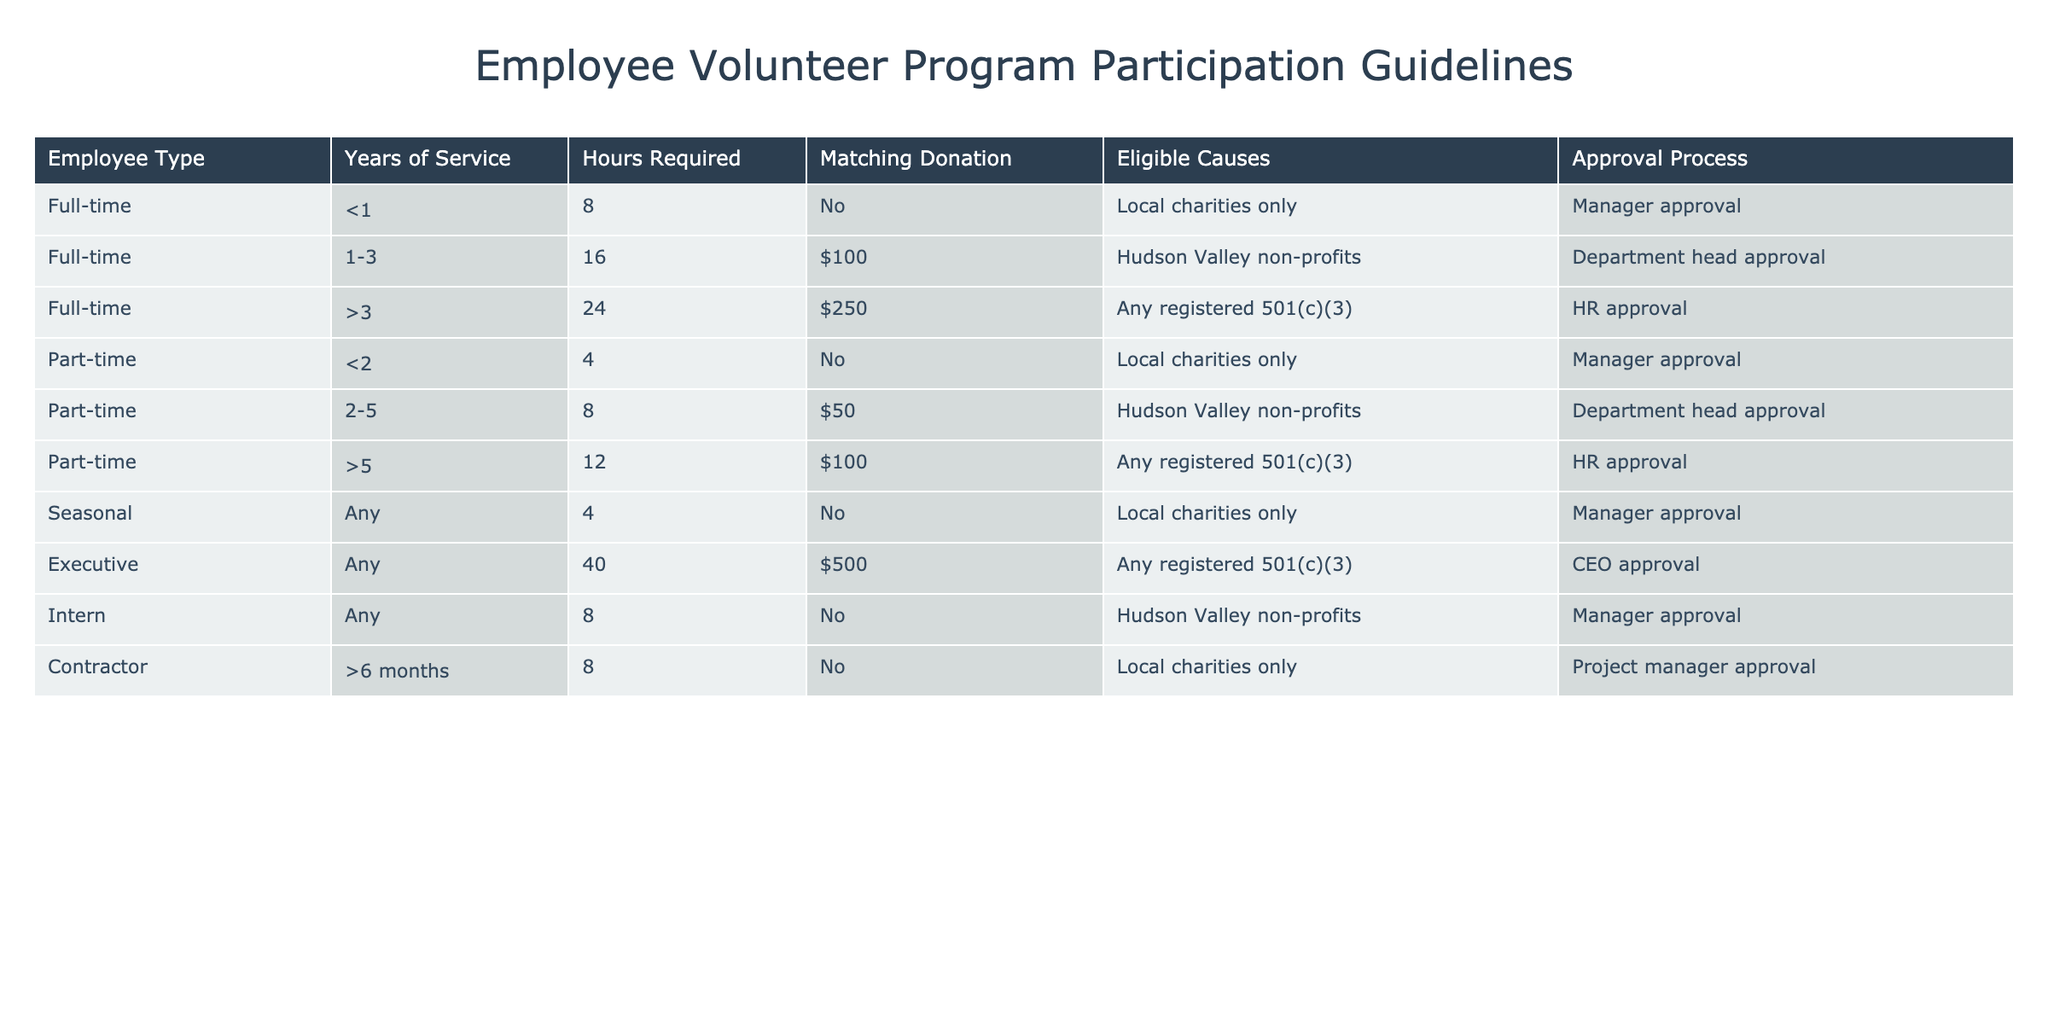What is the approval process for full-time employees with more than 3 years of service? According to the table, full-time employees with more than 3 years of service require HR approval for participation in the volunteer program.
Answer: HR approval How many hours are required for part-time employees with at least 2 years but less than 5 years of service? Part-time employees with 2 to 5 years of service are required to complete 8 hours of volunteer work.
Answer: 8 hours Is a matching donation provided for seasonal employees? The table indicates that seasonal employees do not receive a matching donation for their volunteer hours, as it states "No" under the Matching Donation column for this category.
Answer: No What is the total number of hours required for all full-time employees across different years of service? To find the total hours required for full-time employees, add the hours: 8 (for <1 year) + 16 (for 1-3 years) + 24 (for >3 years) = 48 hours total.
Answer: 48 hours Can part-time employees with less than 2 years of service choose any registered non-profit for their volunteer work? No, part-time employees with less than 2 years of service are only allowed to volunteer for local charities, not any registered 501(c)(3).
Answer: No Which employee type has the highest hourly requirement for volunteering? The executive type has the highest hourly requirement at 40 hours, compared to all other employee types in the table.
Answer: Executive How many eligible causes do full-time employees with more than 3 years of service have? Full-time employees with more than 3 years of service can choose from any registered 501(c)(3) as eligible causes, so they have one option that encompasses a wide range of organizations.
Answer: Any registered 501(c)(3) What is the total matching donation amount available for part-time employees with more than 5 years of service? Part-time employees with more than 5 years of service are eligible for a matching donation of $100, so the total available would be $100 per eligible volunteer.
Answer: $100 Do contractors need approval from the project manager for participating in the volunteer program? Yes, according to the table, contractors who have been working for more than 6 months require approval from the project manager to participate in the volunteer program.
Answer: Yes 